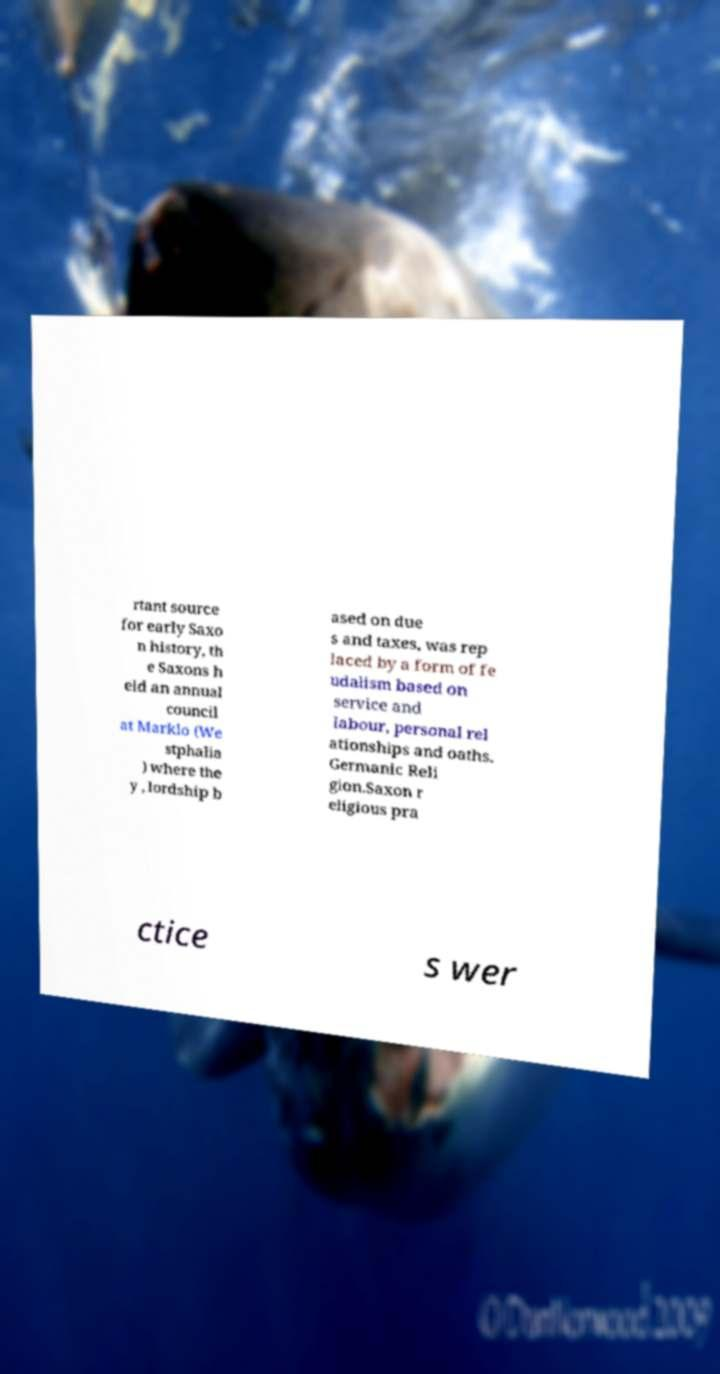Please identify and transcribe the text found in this image. rtant source for early Saxo n history, th e Saxons h eld an annual council at Marklo (We stphalia ) where the y , lordship b ased on due s and taxes, was rep laced by a form of fe udalism based on service and labour, personal rel ationships and oaths. Germanic Reli gion.Saxon r eligious pra ctice s wer 